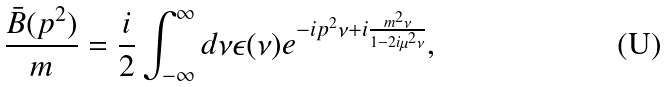Convert formula to latex. <formula><loc_0><loc_0><loc_500><loc_500>\frac { \bar { B } ( p ^ { 2 } ) } { m } = \frac { i } { 2 } \int _ { - \infty } ^ { \infty } d \nu \epsilon ( \nu ) e ^ { - i p ^ { 2 } \nu + i { \frac { m ^ { 2 } \nu } { 1 - 2 i \mu ^ { 2 } \nu } } } ,</formula> 